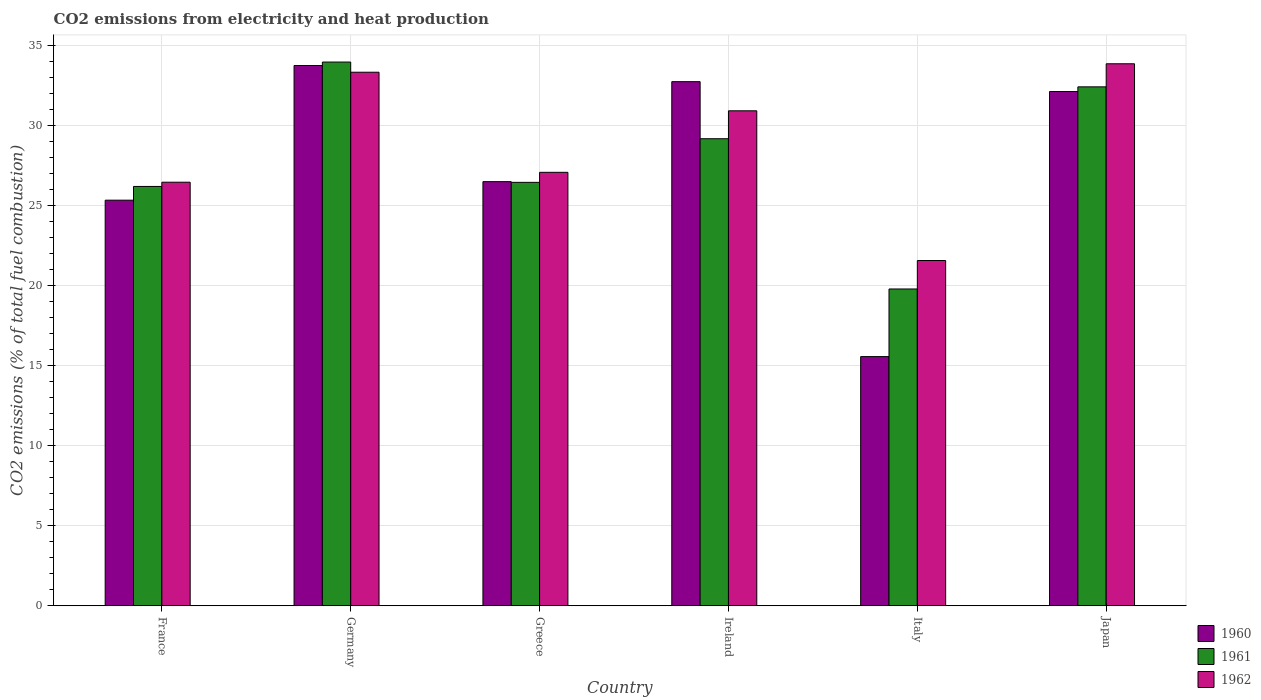How many groups of bars are there?
Your response must be concise. 6. How many bars are there on the 4th tick from the left?
Give a very brief answer. 3. What is the amount of CO2 emitted in 1962 in Germany?
Offer a terse response. 33.31. Across all countries, what is the maximum amount of CO2 emitted in 1960?
Offer a very short reply. 33.72. Across all countries, what is the minimum amount of CO2 emitted in 1962?
Your answer should be compact. 21.55. In which country was the amount of CO2 emitted in 1962 minimum?
Your answer should be very brief. Italy. What is the total amount of CO2 emitted in 1960 in the graph?
Provide a succinct answer. 165.89. What is the difference between the amount of CO2 emitted in 1962 in Germany and that in Italy?
Keep it short and to the point. 11.75. What is the difference between the amount of CO2 emitted in 1962 in France and the amount of CO2 emitted in 1960 in Japan?
Your answer should be compact. -5.66. What is the average amount of CO2 emitted in 1960 per country?
Offer a very short reply. 27.65. What is the difference between the amount of CO2 emitted of/in 1961 and amount of CO2 emitted of/in 1960 in Germany?
Offer a very short reply. 0.22. In how many countries, is the amount of CO2 emitted in 1962 greater than 6 %?
Make the answer very short. 6. What is the ratio of the amount of CO2 emitted in 1960 in Germany to that in Italy?
Ensure brevity in your answer.  2.17. What is the difference between the highest and the second highest amount of CO2 emitted in 1961?
Make the answer very short. -1.55. What is the difference between the highest and the lowest amount of CO2 emitted in 1962?
Ensure brevity in your answer.  12.28. In how many countries, is the amount of CO2 emitted in 1960 greater than the average amount of CO2 emitted in 1960 taken over all countries?
Ensure brevity in your answer.  3. What does the 3rd bar from the left in Ireland represents?
Make the answer very short. 1962. What does the 3rd bar from the right in Greece represents?
Offer a very short reply. 1960. Is it the case that in every country, the sum of the amount of CO2 emitted in 1962 and amount of CO2 emitted in 1960 is greater than the amount of CO2 emitted in 1961?
Provide a short and direct response. Yes. What is the difference between two consecutive major ticks on the Y-axis?
Your answer should be compact. 5. Does the graph contain any zero values?
Your answer should be compact. No. Where does the legend appear in the graph?
Provide a short and direct response. Bottom right. How many legend labels are there?
Offer a terse response. 3. How are the legend labels stacked?
Your answer should be compact. Vertical. What is the title of the graph?
Keep it short and to the point. CO2 emissions from electricity and heat production. Does "1998" appear as one of the legend labels in the graph?
Offer a very short reply. No. What is the label or title of the Y-axis?
Your answer should be very brief. CO2 emissions (% of total fuel combustion). What is the CO2 emissions (% of total fuel combustion) of 1960 in France?
Ensure brevity in your answer.  25.32. What is the CO2 emissions (% of total fuel combustion) in 1961 in France?
Keep it short and to the point. 26.18. What is the CO2 emissions (% of total fuel combustion) in 1962 in France?
Provide a succinct answer. 26.44. What is the CO2 emissions (% of total fuel combustion) of 1960 in Germany?
Your answer should be compact. 33.72. What is the CO2 emissions (% of total fuel combustion) of 1961 in Germany?
Keep it short and to the point. 33.94. What is the CO2 emissions (% of total fuel combustion) of 1962 in Germany?
Provide a succinct answer. 33.31. What is the CO2 emissions (% of total fuel combustion) of 1960 in Greece?
Give a very brief answer. 26.47. What is the CO2 emissions (% of total fuel combustion) in 1961 in Greece?
Provide a short and direct response. 26.43. What is the CO2 emissions (% of total fuel combustion) of 1962 in Greece?
Give a very brief answer. 27.06. What is the CO2 emissions (% of total fuel combustion) in 1960 in Ireland?
Your answer should be compact. 32.72. What is the CO2 emissions (% of total fuel combustion) of 1961 in Ireland?
Keep it short and to the point. 29.15. What is the CO2 emissions (% of total fuel combustion) in 1962 in Ireland?
Provide a succinct answer. 30.9. What is the CO2 emissions (% of total fuel combustion) in 1960 in Italy?
Offer a very short reply. 15.55. What is the CO2 emissions (% of total fuel combustion) in 1961 in Italy?
Make the answer very short. 19.78. What is the CO2 emissions (% of total fuel combustion) of 1962 in Italy?
Keep it short and to the point. 21.55. What is the CO2 emissions (% of total fuel combustion) of 1960 in Japan?
Your answer should be very brief. 32.1. What is the CO2 emissions (% of total fuel combustion) of 1961 in Japan?
Your response must be concise. 32.39. What is the CO2 emissions (% of total fuel combustion) of 1962 in Japan?
Your answer should be very brief. 33.83. Across all countries, what is the maximum CO2 emissions (% of total fuel combustion) in 1960?
Offer a terse response. 33.72. Across all countries, what is the maximum CO2 emissions (% of total fuel combustion) of 1961?
Give a very brief answer. 33.94. Across all countries, what is the maximum CO2 emissions (% of total fuel combustion) of 1962?
Keep it short and to the point. 33.83. Across all countries, what is the minimum CO2 emissions (% of total fuel combustion) in 1960?
Your response must be concise. 15.55. Across all countries, what is the minimum CO2 emissions (% of total fuel combustion) in 1961?
Provide a succinct answer. 19.78. Across all countries, what is the minimum CO2 emissions (% of total fuel combustion) in 1962?
Give a very brief answer. 21.55. What is the total CO2 emissions (% of total fuel combustion) of 1960 in the graph?
Ensure brevity in your answer.  165.89. What is the total CO2 emissions (% of total fuel combustion) of 1961 in the graph?
Make the answer very short. 167.87. What is the total CO2 emissions (% of total fuel combustion) of 1962 in the graph?
Keep it short and to the point. 173.08. What is the difference between the CO2 emissions (% of total fuel combustion) in 1960 in France and that in Germany?
Give a very brief answer. -8.41. What is the difference between the CO2 emissions (% of total fuel combustion) in 1961 in France and that in Germany?
Offer a very short reply. -7.76. What is the difference between the CO2 emissions (% of total fuel combustion) of 1962 in France and that in Germany?
Provide a short and direct response. -6.87. What is the difference between the CO2 emissions (% of total fuel combustion) in 1960 in France and that in Greece?
Provide a short and direct response. -1.16. What is the difference between the CO2 emissions (% of total fuel combustion) of 1961 in France and that in Greece?
Your response must be concise. -0.26. What is the difference between the CO2 emissions (% of total fuel combustion) of 1962 in France and that in Greece?
Make the answer very short. -0.62. What is the difference between the CO2 emissions (% of total fuel combustion) in 1960 in France and that in Ireland?
Your answer should be compact. -7.4. What is the difference between the CO2 emissions (% of total fuel combustion) of 1961 in France and that in Ireland?
Give a very brief answer. -2.98. What is the difference between the CO2 emissions (% of total fuel combustion) in 1962 in France and that in Ireland?
Your response must be concise. -4.46. What is the difference between the CO2 emissions (% of total fuel combustion) in 1960 in France and that in Italy?
Your response must be concise. 9.76. What is the difference between the CO2 emissions (% of total fuel combustion) of 1961 in France and that in Italy?
Give a very brief answer. 6.4. What is the difference between the CO2 emissions (% of total fuel combustion) of 1962 in France and that in Italy?
Give a very brief answer. 4.89. What is the difference between the CO2 emissions (% of total fuel combustion) in 1960 in France and that in Japan?
Your answer should be compact. -6.78. What is the difference between the CO2 emissions (% of total fuel combustion) of 1961 in France and that in Japan?
Give a very brief answer. -6.22. What is the difference between the CO2 emissions (% of total fuel combustion) in 1962 in France and that in Japan?
Provide a short and direct response. -7.39. What is the difference between the CO2 emissions (% of total fuel combustion) in 1960 in Germany and that in Greece?
Make the answer very short. 7.25. What is the difference between the CO2 emissions (% of total fuel combustion) in 1961 in Germany and that in Greece?
Make the answer very short. 7.51. What is the difference between the CO2 emissions (% of total fuel combustion) of 1962 in Germany and that in Greece?
Keep it short and to the point. 6.25. What is the difference between the CO2 emissions (% of total fuel combustion) of 1960 in Germany and that in Ireland?
Your answer should be compact. 1.01. What is the difference between the CO2 emissions (% of total fuel combustion) of 1961 in Germany and that in Ireland?
Give a very brief answer. 4.79. What is the difference between the CO2 emissions (% of total fuel combustion) in 1962 in Germany and that in Ireland?
Make the answer very short. 2.41. What is the difference between the CO2 emissions (% of total fuel combustion) in 1960 in Germany and that in Italy?
Make the answer very short. 18.17. What is the difference between the CO2 emissions (% of total fuel combustion) in 1961 in Germany and that in Italy?
Your answer should be very brief. 14.16. What is the difference between the CO2 emissions (% of total fuel combustion) in 1962 in Germany and that in Italy?
Keep it short and to the point. 11.75. What is the difference between the CO2 emissions (% of total fuel combustion) of 1960 in Germany and that in Japan?
Provide a succinct answer. 1.62. What is the difference between the CO2 emissions (% of total fuel combustion) of 1961 in Germany and that in Japan?
Offer a very short reply. 1.55. What is the difference between the CO2 emissions (% of total fuel combustion) of 1962 in Germany and that in Japan?
Keep it short and to the point. -0.53. What is the difference between the CO2 emissions (% of total fuel combustion) in 1960 in Greece and that in Ireland?
Your answer should be compact. -6.24. What is the difference between the CO2 emissions (% of total fuel combustion) in 1961 in Greece and that in Ireland?
Your response must be concise. -2.72. What is the difference between the CO2 emissions (% of total fuel combustion) in 1962 in Greece and that in Ireland?
Provide a short and direct response. -3.84. What is the difference between the CO2 emissions (% of total fuel combustion) of 1960 in Greece and that in Italy?
Make the answer very short. 10.92. What is the difference between the CO2 emissions (% of total fuel combustion) in 1961 in Greece and that in Italy?
Make the answer very short. 6.66. What is the difference between the CO2 emissions (% of total fuel combustion) in 1962 in Greece and that in Italy?
Your answer should be compact. 5.51. What is the difference between the CO2 emissions (% of total fuel combustion) in 1960 in Greece and that in Japan?
Your response must be concise. -5.63. What is the difference between the CO2 emissions (% of total fuel combustion) of 1961 in Greece and that in Japan?
Give a very brief answer. -5.96. What is the difference between the CO2 emissions (% of total fuel combustion) in 1962 in Greece and that in Japan?
Your response must be concise. -6.78. What is the difference between the CO2 emissions (% of total fuel combustion) of 1960 in Ireland and that in Italy?
Offer a very short reply. 17.16. What is the difference between the CO2 emissions (% of total fuel combustion) of 1961 in Ireland and that in Italy?
Provide a succinct answer. 9.38. What is the difference between the CO2 emissions (% of total fuel combustion) in 1962 in Ireland and that in Italy?
Your answer should be compact. 9.35. What is the difference between the CO2 emissions (% of total fuel combustion) in 1960 in Ireland and that in Japan?
Your answer should be compact. 0.61. What is the difference between the CO2 emissions (% of total fuel combustion) of 1961 in Ireland and that in Japan?
Give a very brief answer. -3.24. What is the difference between the CO2 emissions (% of total fuel combustion) in 1962 in Ireland and that in Japan?
Provide a succinct answer. -2.94. What is the difference between the CO2 emissions (% of total fuel combustion) in 1960 in Italy and that in Japan?
Your response must be concise. -16.55. What is the difference between the CO2 emissions (% of total fuel combustion) in 1961 in Italy and that in Japan?
Offer a very short reply. -12.62. What is the difference between the CO2 emissions (% of total fuel combustion) of 1962 in Italy and that in Japan?
Offer a terse response. -12.28. What is the difference between the CO2 emissions (% of total fuel combustion) in 1960 in France and the CO2 emissions (% of total fuel combustion) in 1961 in Germany?
Give a very brief answer. -8.62. What is the difference between the CO2 emissions (% of total fuel combustion) of 1960 in France and the CO2 emissions (% of total fuel combustion) of 1962 in Germany?
Offer a very short reply. -7.99. What is the difference between the CO2 emissions (% of total fuel combustion) of 1961 in France and the CO2 emissions (% of total fuel combustion) of 1962 in Germany?
Your answer should be very brief. -7.13. What is the difference between the CO2 emissions (% of total fuel combustion) of 1960 in France and the CO2 emissions (% of total fuel combustion) of 1961 in Greece?
Provide a succinct answer. -1.11. What is the difference between the CO2 emissions (% of total fuel combustion) in 1960 in France and the CO2 emissions (% of total fuel combustion) in 1962 in Greece?
Keep it short and to the point. -1.74. What is the difference between the CO2 emissions (% of total fuel combustion) of 1961 in France and the CO2 emissions (% of total fuel combustion) of 1962 in Greece?
Make the answer very short. -0.88. What is the difference between the CO2 emissions (% of total fuel combustion) of 1960 in France and the CO2 emissions (% of total fuel combustion) of 1961 in Ireland?
Your answer should be very brief. -3.84. What is the difference between the CO2 emissions (% of total fuel combustion) in 1960 in France and the CO2 emissions (% of total fuel combustion) in 1962 in Ireland?
Provide a succinct answer. -5.58. What is the difference between the CO2 emissions (% of total fuel combustion) of 1961 in France and the CO2 emissions (% of total fuel combustion) of 1962 in Ireland?
Offer a terse response. -4.72. What is the difference between the CO2 emissions (% of total fuel combustion) of 1960 in France and the CO2 emissions (% of total fuel combustion) of 1961 in Italy?
Keep it short and to the point. 5.54. What is the difference between the CO2 emissions (% of total fuel combustion) of 1960 in France and the CO2 emissions (% of total fuel combustion) of 1962 in Italy?
Provide a short and direct response. 3.77. What is the difference between the CO2 emissions (% of total fuel combustion) in 1961 in France and the CO2 emissions (% of total fuel combustion) in 1962 in Italy?
Offer a very short reply. 4.62. What is the difference between the CO2 emissions (% of total fuel combustion) in 1960 in France and the CO2 emissions (% of total fuel combustion) in 1961 in Japan?
Offer a very short reply. -7.07. What is the difference between the CO2 emissions (% of total fuel combustion) of 1960 in France and the CO2 emissions (% of total fuel combustion) of 1962 in Japan?
Provide a short and direct response. -8.51. What is the difference between the CO2 emissions (% of total fuel combustion) in 1961 in France and the CO2 emissions (% of total fuel combustion) in 1962 in Japan?
Make the answer very short. -7.66. What is the difference between the CO2 emissions (% of total fuel combustion) of 1960 in Germany and the CO2 emissions (% of total fuel combustion) of 1961 in Greece?
Offer a terse response. 7.29. What is the difference between the CO2 emissions (% of total fuel combustion) of 1960 in Germany and the CO2 emissions (% of total fuel combustion) of 1962 in Greece?
Provide a succinct answer. 6.67. What is the difference between the CO2 emissions (% of total fuel combustion) in 1961 in Germany and the CO2 emissions (% of total fuel combustion) in 1962 in Greece?
Offer a very short reply. 6.88. What is the difference between the CO2 emissions (% of total fuel combustion) in 1960 in Germany and the CO2 emissions (% of total fuel combustion) in 1961 in Ireland?
Keep it short and to the point. 4.57. What is the difference between the CO2 emissions (% of total fuel combustion) in 1960 in Germany and the CO2 emissions (% of total fuel combustion) in 1962 in Ireland?
Offer a very short reply. 2.83. What is the difference between the CO2 emissions (% of total fuel combustion) of 1961 in Germany and the CO2 emissions (% of total fuel combustion) of 1962 in Ireland?
Ensure brevity in your answer.  3.04. What is the difference between the CO2 emissions (% of total fuel combustion) in 1960 in Germany and the CO2 emissions (% of total fuel combustion) in 1961 in Italy?
Provide a succinct answer. 13.95. What is the difference between the CO2 emissions (% of total fuel combustion) in 1960 in Germany and the CO2 emissions (% of total fuel combustion) in 1962 in Italy?
Make the answer very short. 12.17. What is the difference between the CO2 emissions (% of total fuel combustion) of 1961 in Germany and the CO2 emissions (% of total fuel combustion) of 1962 in Italy?
Provide a succinct answer. 12.39. What is the difference between the CO2 emissions (% of total fuel combustion) in 1960 in Germany and the CO2 emissions (% of total fuel combustion) in 1961 in Japan?
Make the answer very short. 1.33. What is the difference between the CO2 emissions (% of total fuel combustion) in 1960 in Germany and the CO2 emissions (% of total fuel combustion) in 1962 in Japan?
Keep it short and to the point. -0.11. What is the difference between the CO2 emissions (% of total fuel combustion) of 1961 in Germany and the CO2 emissions (% of total fuel combustion) of 1962 in Japan?
Make the answer very short. 0.11. What is the difference between the CO2 emissions (% of total fuel combustion) in 1960 in Greece and the CO2 emissions (% of total fuel combustion) in 1961 in Ireland?
Keep it short and to the point. -2.68. What is the difference between the CO2 emissions (% of total fuel combustion) of 1960 in Greece and the CO2 emissions (% of total fuel combustion) of 1962 in Ireland?
Your response must be concise. -4.42. What is the difference between the CO2 emissions (% of total fuel combustion) in 1961 in Greece and the CO2 emissions (% of total fuel combustion) in 1962 in Ireland?
Provide a short and direct response. -4.47. What is the difference between the CO2 emissions (% of total fuel combustion) of 1960 in Greece and the CO2 emissions (% of total fuel combustion) of 1961 in Italy?
Make the answer very short. 6.7. What is the difference between the CO2 emissions (% of total fuel combustion) in 1960 in Greece and the CO2 emissions (% of total fuel combustion) in 1962 in Italy?
Your response must be concise. 4.92. What is the difference between the CO2 emissions (% of total fuel combustion) in 1961 in Greece and the CO2 emissions (% of total fuel combustion) in 1962 in Italy?
Provide a succinct answer. 4.88. What is the difference between the CO2 emissions (% of total fuel combustion) of 1960 in Greece and the CO2 emissions (% of total fuel combustion) of 1961 in Japan?
Give a very brief answer. -5.92. What is the difference between the CO2 emissions (% of total fuel combustion) in 1960 in Greece and the CO2 emissions (% of total fuel combustion) in 1962 in Japan?
Keep it short and to the point. -7.36. What is the difference between the CO2 emissions (% of total fuel combustion) of 1961 in Greece and the CO2 emissions (% of total fuel combustion) of 1962 in Japan?
Give a very brief answer. -7.4. What is the difference between the CO2 emissions (% of total fuel combustion) in 1960 in Ireland and the CO2 emissions (% of total fuel combustion) in 1961 in Italy?
Provide a short and direct response. 12.94. What is the difference between the CO2 emissions (% of total fuel combustion) of 1960 in Ireland and the CO2 emissions (% of total fuel combustion) of 1962 in Italy?
Offer a very short reply. 11.16. What is the difference between the CO2 emissions (% of total fuel combustion) in 1961 in Ireland and the CO2 emissions (% of total fuel combustion) in 1962 in Italy?
Give a very brief answer. 7.6. What is the difference between the CO2 emissions (% of total fuel combustion) in 1960 in Ireland and the CO2 emissions (% of total fuel combustion) in 1961 in Japan?
Your response must be concise. 0.32. What is the difference between the CO2 emissions (% of total fuel combustion) in 1960 in Ireland and the CO2 emissions (% of total fuel combustion) in 1962 in Japan?
Your answer should be compact. -1.12. What is the difference between the CO2 emissions (% of total fuel combustion) in 1961 in Ireland and the CO2 emissions (% of total fuel combustion) in 1962 in Japan?
Your answer should be very brief. -4.68. What is the difference between the CO2 emissions (% of total fuel combustion) in 1960 in Italy and the CO2 emissions (% of total fuel combustion) in 1961 in Japan?
Offer a very short reply. -16.84. What is the difference between the CO2 emissions (% of total fuel combustion) in 1960 in Italy and the CO2 emissions (% of total fuel combustion) in 1962 in Japan?
Your answer should be compact. -18.28. What is the difference between the CO2 emissions (% of total fuel combustion) in 1961 in Italy and the CO2 emissions (% of total fuel combustion) in 1962 in Japan?
Make the answer very short. -14.06. What is the average CO2 emissions (% of total fuel combustion) in 1960 per country?
Your response must be concise. 27.65. What is the average CO2 emissions (% of total fuel combustion) in 1961 per country?
Offer a very short reply. 27.98. What is the average CO2 emissions (% of total fuel combustion) in 1962 per country?
Ensure brevity in your answer.  28.85. What is the difference between the CO2 emissions (% of total fuel combustion) in 1960 and CO2 emissions (% of total fuel combustion) in 1961 in France?
Make the answer very short. -0.86. What is the difference between the CO2 emissions (% of total fuel combustion) in 1960 and CO2 emissions (% of total fuel combustion) in 1962 in France?
Give a very brief answer. -1.12. What is the difference between the CO2 emissions (% of total fuel combustion) of 1961 and CO2 emissions (% of total fuel combustion) of 1962 in France?
Offer a terse response. -0.26. What is the difference between the CO2 emissions (% of total fuel combustion) of 1960 and CO2 emissions (% of total fuel combustion) of 1961 in Germany?
Your response must be concise. -0.21. What is the difference between the CO2 emissions (% of total fuel combustion) in 1960 and CO2 emissions (% of total fuel combustion) in 1962 in Germany?
Provide a short and direct response. 0.42. What is the difference between the CO2 emissions (% of total fuel combustion) of 1961 and CO2 emissions (% of total fuel combustion) of 1962 in Germany?
Provide a succinct answer. 0.63. What is the difference between the CO2 emissions (% of total fuel combustion) in 1960 and CO2 emissions (% of total fuel combustion) in 1961 in Greece?
Make the answer very short. 0.04. What is the difference between the CO2 emissions (% of total fuel combustion) in 1960 and CO2 emissions (% of total fuel combustion) in 1962 in Greece?
Offer a very short reply. -0.58. What is the difference between the CO2 emissions (% of total fuel combustion) of 1961 and CO2 emissions (% of total fuel combustion) of 1962 in Greece?
Provide a succinct answer. -0.63. What is the difference between the CO2 emissions (% of total fuel combustion) of 1960 and CO2 emissions (% of total fuel combustion) of 1961 in Ireland?
Your response must be concise. 3.56. What is the difference between the CO2 emissions (% of total fuel combustion) of 1960 and CO2 emissions (% of total fuel combustion) of 1962 in Ireland?
Offer a terse response. 1.82. What is the difference between the CO2 emissions (% of total fuel combustion) of 1961 and CO2 emissions (% of total fuel combustion) of 1962 in Ireland?
Make the answer very short. -1.74. What is the difference between the CO2 emissions (% of total fuel combustion) of 1960 and CO2 emissions (% of total fuel combustion) of 1961 in Italy?
Keep it short and to the point. -4.22. What is the difference between the CO2 emissions (% of total fuel combustion) of 1960 and CO2 emissions (% of total fuel combustion) of 1962 in Italy?
Your answer should be very brief. -6. What is the difference between the CO2 emissions (% of total fuel combustion) of 1961 and CO2 emissions (% of total fuel combustion) of 1962 in Italy?
Your answer should be compact. -1.78. What is the difference between the CO2 emissions (% of total fuel combustion) of 1960 and CO2 emissions (% of total fuel combustion) of 1961 in Japan?
Offer a terse response. -0.29. What is the difference between the CO2 emissions (% of total fuel combustion) in 1960 and CO2 emissions (% of total fuel combustion) in 1962 in Japan?
Ensure brevity in your answer.  -1.73. What is the difference between the CO2 emissions (% of total fuel combustion) of 1961 and CO2 emissions (% of total fuel combustion) of 1962 in Japan?
Offer a terse response. -1.44. What is the ratio of the CO2 emissions (% of total fuel combustion) in 1960 in France to that in Germany?
Your answer should be very brief. 0.75. What is the ratio of the CO2 emissions (% of total fuel combustion) of 1961 in France to that in Germany?
Provide a short and direct response. 0.77. What is the ratio of the CO2 emissions (% of total fuel combustion) in 1962 in France to that in Germany?
Make the answer very short. 0.79. What is the ratio of the CO2 emissions (% of total fuel combustion) in 1960 in France to that in Greece?
Keep it short and to the point. 0.96. What is the ratio of the CO2 emissions (% of total fuel combustion) of 1961 in France to that in Greece?
Your answer should be very brief. 0.99. What is the ratio of the CO2 emissions (% of total fuel combustion) in 1962 in France to that in Greece?
Provide a short and direct response. 0.98. What is the ratio of the CO2 emissions (% of total fuel combustion) in 1960 in France to that in Ireland?
Keep it short and to the point. 0.77. What is the ratio of the CO2 emissions (% of total fuel combustion) in 1961 in France to that in Ireland?
Give a very brief answer. 0.9. What is the ratio of the CO2 emissions (% of total fuel combustion) of 1962 in France to that in Ireland?
Keep it short and to the point. 0.86. What is the ratio of the CO2 emissions (% of total fuel combustion) in 1960 in France to that in Italy?
Make the answer very short. 1.63. What is the ratio of the CO2 emissions (% of total fuel combustion) in 1961 in France to that in Italy?
Keep it short and to the point. 1.32. What is the ratio of the CO2 emissions (% of total fuel combustion) in 1962 in France to that in Italy?
Give a very brief answer. 1.23. What is the ratio of the CO2 emissions (% of total fuel combustion) of 1960 in France to that in Japan?
Keep it short and to the point. 0.79. What is the ratio of the CO2 emissions (% of total fuel combustion) of 1961 in France to that in Japan?
Provide a succinct answer. 0.81. What is the ratio of the CO2 emissions (% of total fuel combustion) in 1962 in France to that in Japan?
Give a very brief answer. 0.78. What is the ratio of the CO2 emissions (% of total fuel combustion) of 1960 in Germany to that in Greece?
Your response must be concise. 1.27. What is the ratio of the CO2 emissions (% of total fuel combustion) of 1961 in Germany to that in Greece?
Your answer should be compact. 1.28. What is the ratio of the CO2 emissions (% of total fuel combustion) of 1962 in Germany to that in Greece?
Your answer should be very brief. 1.23. What is the ratio of the CO2 emissions (% of total fuel combustion) in 1960 in Germany to that in Ireland?
Ensure brevity in your answer.  1.03. What is the ratio of the CO2 emissions (% of total fuel combustion) of 1961 in Germany to that in Ireland?
Your answer should be very brief. 1.16. What is the ratio of the CO2 emissions (% of total fuel combustion) of 1962 in Germany to that in Ireland?
Offer a terse response. 1.08. What is the ratio of the CO2 emissions (% of total fuel combustion) of 1960 in Germany to that in Italy?
Provide a short and direct response. 2.17. What is the ratio of the CO2 emissions (% of total fuel combustion) in 1961 in Germany to that in Italy?
Keep it short and to the point. 1.72. What is the ratio of the CO2 emissions (% of total fuel combustion) of 1962 in Germany to that in Italy?
Make the answer very short. 1.55. What is the ratio of the CO2 emissions (% of total fuel combustion) in 1960 in Germany to that in Japan?
Your answer should be very brief. 1.05. What is the ratio of the CO2 emissions (% of total fuel combustion) in 1961 in Germany to that in Japan?
Offer a very short reply. 1.05. What is the ratio of the CO2 emissions (% of total fuel combustion) of 1962 in Germany to that in Japan?
Keep it short and to the point. 0.98. What is the ratio of the CO2 emissions (% of total fuel combustion) of 1960 in Greece to that in Ireland?
Your answer should be very brief. 0.81. What is the ratio of the CO2 emissions (% of total fuel combustion) in 1961 in Greece to that in Ireland?
Offer a terse response. 0.91. What is the ratio of the CO2 emissions (% of total fuel combustion) of 1962 in Greece to that in Ireland?
Give a very brief answer. 0.88. What is the ratio of the CO2 emissions (% of total fuel combustion) of 1960 in Greece to that in Italy?
Your response must be concise. 1.7. What is the ratio of the CO2 emissions (% of total fuel combustion) in 1961 in Greece to that in Italy?
Provide a short and direct response. 1.34. What is the ratio of the CO2 emissions (% of total fuel combustion) in 1962 in Greece to that in Italy?
Provide a succinct answer. 1.26. What is the ratio of the CO2 emissions (% of total fuel combustion) of 1960 in Greece to that in Japan?
Ensure brevity in your answer.  0.82. What is the ratio of the CO2 emissions (% of total fuel combustion) of 1961 in Greece to that in Japan?
Your response must be concise. 0.82. What is the ratio of the CO2 emissions (% of total fuel combustion) in 1962 in Greece to that in Japan?
Keep it short and to the point. 0.8. What is the ratio of the CO2 emissions (% of total fuel combustion) in 1960 in Ireland to that in Italy?
Ensure brevity in your answer.  2.1. What is the ratio of the CO2 emissions (% of total fuel combustion) in 1961 in Ireland to that in Italy?
Provide a short and direct response. 1.47. What is the ratio of the CO2 emissions (% of total fuel combustion) of 1962 in Ireland to that in Italy?
Your answer should be very brief. 1.43. What is the ratio of the CO2 emissions (% of total fuel combustion) in 1960 in Ireland to that in Japan?
Your answer should be compact. 1.02. What is the ratio of the CO2 emissions (% of total fuel combustion) in 1962 in Ireland to that in Japan?
Ensure brevity in your answer.  0.91. What is the ratio of the CO2 emissions (% of total fuel combustion) in 1960 in Italy to that in Japan?
Offer a very short reply. 0.48. What is the ratio of the CO2 emissions (% of total fuel combustion) in 1961 in Italy to that in Japan?
Your answer should be very brief. 0.61. What is the ratio of the CO2 emissions (% of total fuel combustion) of 1962 in Italy to that in Japan?
Give a very brief answer. 0.64. What is the difference between the highest and the second highest CO2 emissions (% of total fuel combustion) in 1960?
Give a very brief answer. 1.01. What is the difference between the highest and the second highest CO2 emissions (% of total fuel combustion) of 1961?
Ensure brevity in your answer.  1.55. What is the difference between the highest and the second highest CO2 emissions (% of total fuel combustion) of 1962?
Offer a very short reply. 0.53. What is the difference between the highest and the lowest CO2 emissions (% of total fuel combustion) in 1960?
Your answer should be very brief. 18.17. What is the difference between the highest and the lowest CO2 emissions (% of total fuel combustion) in 1961?
Make the answer very short. 14.16. What is the difference between the highest and the lowest CO2 emissions (% of total fuel combustion) of 1962?
Your answer should be compact. 12.28. 